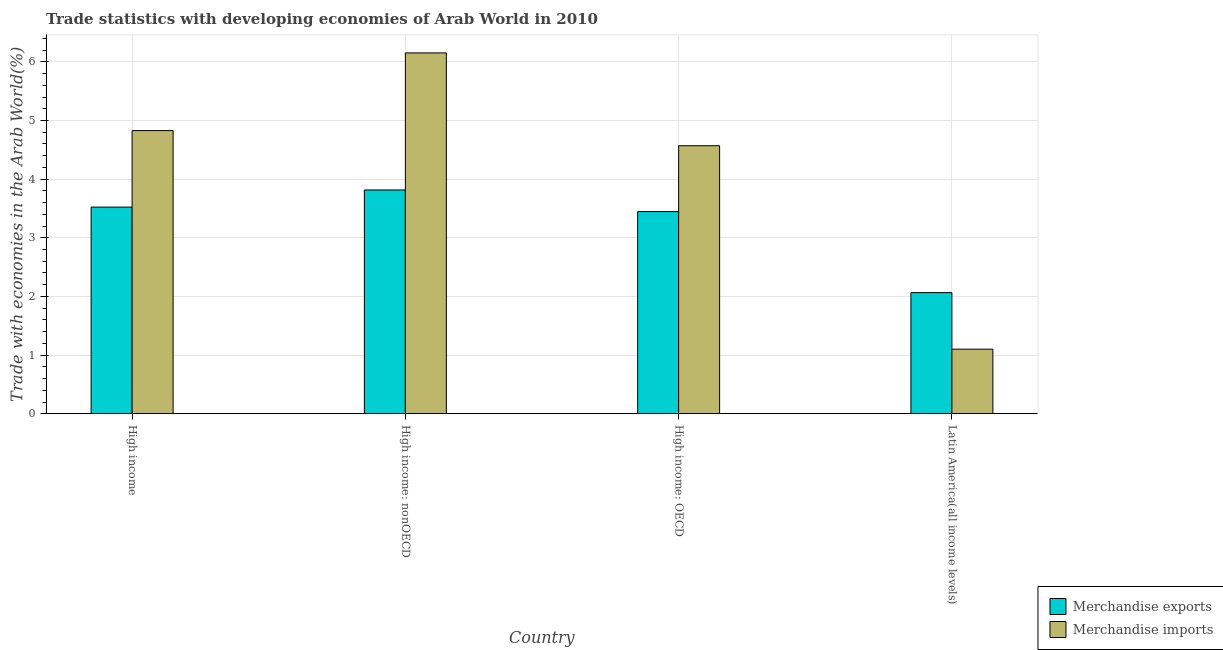How many different coloured bars are there?
Offer a terse response. 2. How many groups of bars are there?
Keep it short and to the point. 4. Are the number of bars per tick equal to the number of legend labels?
Your response must be concise. Yes. Are the number of bars on each tick of the X-axis equal?
Your answer should be very brief. Yes. How many bars are there on the 4th tick from the left?
Keep it short and to the point. 2. What is the label of the 3rd group of bars from the left?
Ensure brevity in your answer.  High income: OECD. In how many cases, is the number of bars for a given country not equal to the number of legend labels?
Give a very brief answer. 0. What is the merchandise exports in High income: nonOECD?
Your answer should be very brief. 3.82. Across all countries, what is the maximum merchandise imports?
Offer a terse response. 6.15. Across all countries, what is the minimum merchandise exports?
Offer a very short reply. 2.07. In which country was the merchandise imports maximum?
Make the answer very short. High income: nonOECD. In which country was the merchandise imports minimum?
Keep it short and to the point. Latin America(all income levels). What is the total merchandise imports in the graph?
Your response must be concise. 16.65. What is the difference between the merchandise imports in High income and that in High income: nonOECD?
Provide a succinct answer. -1.32. What is the difference between the merchandise exports in Latin America(all income levels) and the merchandise imports in High income: nonOECD?
Your response must be concise. -4.09. What is the average merchandise imports per country?
Offer a very short reply. 4.16. What is the difference between the merchandise imports and merchandise exports in High income: nonOECD?
Keep it short and to the point. 2.34. What is the ratio of the merchandise imports in High income to that in High income: nonOECD?
Your answer should be compact. 0.78. Is the difference between the merchandise imports in High income: OECD and Latin America(all income levels) greater than the difference between the merchandise exports in High income: OECD and Latin America(all income levels)?
Your response must be concise. Yes. What is the difference between the highest and the second highest merchandise exports?
Offer a very short reply. 0.29. What is the difference between the highest and the lowest merchandise exports?
Your answer should be compact. 1.75. What does the 2nd bar from the left in High income represents?
Your answer should be very brief. Merchandise imports. What does the 2nd bar from the right in Latin America(all income levels) represents?
Your answer should be very brief. Merchandise exports. How many countries are there in the graph?
Provide a short and direct response. 4. Does the graph contain any zero values?
Make the answer very short. No. Does the graph contain grids?
Your response must be concise. Yes. How many legend labels are there?
Provide a succinct answer. 2. What is the title of the graph?
Provide a short and direct response. Trade statistics with developing economies of Arab World in 2010. What is the label or title of the X-axis?
Provide a short and direct response. Country. What is the label or title of the Y-axis?
Make the answer very short. Trade with economies in the Arab World(%). What is the Trade with economies in the Arab World(%) in Merchandise exports in High income?
Give a very brief answer. 3.52. What is the Trade with economies in the Arab World(%) in Merchandise imports in High income?
Provide a short and direct response. 4.83. What is the Trade with economies in the Arab World(%) in Merchandise exports in High income: nonOECD?
Your answer should be compact. 3.82. What is the Trade with economies in the Arab World(%) in Merchandise imports in High income: nonOECD?
Offer a terse response. 6.15. What is the Trade with economies in the Arab World(%) of Merchandise exports in High income: OECD?
Keep it short and to the point. 3.45. What is the Trade with economies in the Arab World(%) in Merchandise imports in High income: OECD?
Give a very brief answer. 4.57. What is the Trade with economies in the Arab World(%) of Merchandise exports in Latin America(all income levels)?
Your response must be concise. 2.07. What is the Trade with economies in the Arab World(%) of Merchandise imports in Latin America(all income levels)?
Give a very brief answer. 1.1. Across all countries, what is the maximum Trade with economies in the Arab World(%) of Merchandise exports?
Offer a very short reply. 3.82. Across all countries, what is the maximum Trade with economies in the Arab World(%) of Merchandise imports?
Provide a short and direct response. 6.15. Across all countries, what is the minimum Trade with economies in the Arab World(%) in Merchandise exports?
Provide a short and direct response. 2.07. Across all countries, what is the minimum Trade with economies in the Arab World(%) in Merchandise imports?
Provide a succinct answer. 1.1. What is the total Trade with economies in the Arab World(%) of Merchandise exports in the graph?
Keep it short and to the point. 12.85. What is the total Trade with economies in the Arab World(%) of Merchandise imports in the graph?
Your answer should be compact. 16.65. What is the difference between the Trade with economies in the Arab World(%) of Merchandise exports in High income and that in High income: nonOECD?
Your answer should be compact. -0.29. What is the difference between the Trade with economies in the Arab World(%) of Merchandise imports in High income and that in High income: nonOECD?
Offer a terse response. -1.32. What is the difference between the Trade with economies in the Arab World(%) of Merchandise exports in High income and that in High income: OECD?
Offer a very short reply. 0.08. What is the difference between the Trade with economies in the Arab World(%) in Merchandise imports in High income and that in High income: OECD?
Provide a succinct answer. 0.26. What is the difference between the Trade with economies in the Arab World(%) in Merchandise exports in High income and that in Latin America(all income levels)?
Offer a very short reply. 1.46. What is the difference between the Trade with economies in the Arab World(%) of Merchandise imports in High income and that in Latin America(all income levels)?
Your answer should be very brief. 3.73. What is the difference between the Trade with economies in the Arab World(%) in Merchandise exports in High income: nonOECD and that in High income: OECD?
Offer a very short reply. 0.37. What is the difference between the Trade with economies in the Arab World(%) in Merchandise imports in High income: nonOECD and that in High income: OECD?
Offer a terse response. 1.58. What is the difference between the Trade with economies in the Arab World(%) of Merchandise exports in High income: nonOECD and that in Latin America(all income levels)?
Give a very brief answer. 1.75. What is the difference between the Trade with economies in the Arab World(%) in Merchandise imports in High income: nonOECD and that in Latin America(all income levels)?
Offer a terse response. 5.05. What is the difference between the Trade with economies in the Arab World(%) in Merchandise exports in High income: OECD and that in Latin America(all income levels)?
Your answer should be compact. 1.38. What is the difference between the Trade with economies in the Arab World(%) of Merchandise imports in High income: OECD and that in Latin America(all income levels)?
Keep it short and to the point. 3.47. What is the difference between the Trade with economies in the Arab World(%) in Merchandise exports in High income and the Trade with economies in the Arab World(%) in Merchandise imports in High income: nonOECD?
Provide a succinct answer. -2.63. What is the difference between the Trade with economies in the Arab World(%) of Merchandise exports in High income and the Trade with economies in the Arab World(%) of Merchandise imports in High income: OECD?
Give a very brief answer. -1.05. What is the difference between the Trade with economies in the Arab World(%) of Merchandise exports in High income and the Trade with economies in the Arab World(%) of Merchandise imports in Latin America(all income levels)?
Your answer should be compact. 2.42. What is the difference between the Trade with economies in the Arab World(%) in Merchandise exports in High income: nonOECD and the Trade with economies in the Arab World(%) in Merchandise imports in High income: OECD?
Provide a short and direct response. -0.75. What is the difference between the Trade with economies in the Arab World(%) in Merchandise exports in High income: nonOECD and the Trade with economies in the Arab World(%) in Merchandise imports in Latin America(all income levels)?
Provide a short and direct response. 2.71. What is the difference between the Trade with economies in the Arab World(%) of Merchandise exports in High income: OECD and the Trade with economies in the Arab World(%) of Merchandise imports in Latin America(all income levels)?
Provide a short and direct response. 2.35. What is the average Trade with economies in the Arab World(%) of Merchandise exports per country?
Ensure brevity in your answer.  3.21. What is the average Trade with economies in the Arab World(%) of Merchandise imports per country?
Give a very brief answer. 4.16. What is the difference between the Trade with economies in the Arab World(%) in Merchandise exports and Trade with economies in the Arab World(%) in Merchandise imports in High income?
Your answer should be compact. -1.3. What is the difference between the Trade with economies in the Arab World(%) of Merchandise exports and Trade with economies in the Arab World(%) of Merchandise imports in High income: nonOECD?
Give a very brief answer. -2.34. What is the difference between the Trade with economies in the Arab World(%) of Merchandise exports and Trade with economies in the Arab World(%) of Merchandise imports in High income: OECD?
Provide a succinct answer. -1.12. What is the difference between the Trade with economies in the Arab World(%) in Merchandise exports and Trade with economies in the Arab World(%) in Merchandise imports in Latin America(all income levels)?
Provide a short and direct response. 0.96. What is the ratio of the Trade with economies in the Arab World(%) in Merchandise exports in High income to that in High income: nonOECD?
Make the answer very short. 0.92. What is the ratio of the Trade with economies in the Arab World(%) in Merchandise imports in High income to that in High income: nonOECD?
Give a very brief answer. 0.78. What is the ratio of the Trade with economies in the Arab World(%) in Merchandise exports in High income to that in High income: OECD?
Ensure brevity in your answer.  1.02. What is the ratio of the Trade with economies in the Arab World(%) in Merchandise imports in High income to that in High income: OECD?
Ensure brevity in your answer.  1.06. What is the ratio of the Trade with economies in the Arab World(%) of Merchandise exports in High income to that in Latin America(all income levels)?
Your response must be concise. 1.71. What is the ratio of the Trade with economies in the Arab World(%) of Merchandise imports in High income to that in Latin America(all income levels)?
Offer a very short reply. 4.38. What is the ratio of the Trade with economies in the Arab World(%) in Merchandise exports in High income: nonOECD to that in High income: OECD?
Your answer should be very brief. 1.11. What is the ratio of the Trade with economies in the Arab World(%) in Merchandise imports in High income: nonOECD to that in High income: OECD?
Offer a very short reply. 1.35. What is the ratio of the Trade with economies in the Arab World(%) of Merchandise exports in High income: nonOECD to that in Latin America(all income levels)?
Offer a terse response. 1.85. What is the ratio of the Trade with economies in the Arab World(%) in Merchandise imports in High income: nonOECD to that in Latin America(all income levels)?
Offer a very short reply. 5.59. What is the ratio of the Trade with economies in the Arab World(%) of Merchandise exports in High income: OECD to that in Latin America(all income levels)?
Offer a terse response. 1.67. What is the ratio of the Trade with economies in the Arab World(%) in Merchandise imports in High income: OECD to that in Latin America(all income levels)?
Make the answer very short. 4.15. What is the difference between the highest and the second highest Trade with economies in the Arab World(%) of Merchandise exports?
Make the answer very short. 0.29. What is the difference between the highest and the second highest Trade with economies in the Arab World(%) of Merchandise imports?
Offer a very short reply. 1.32. What is the difference between the highest and the lowest Trade with economies in the Arab World(%) in Merchandise exports?
Offer a very short reply. 1.75. What is the difference between the highest and the lowest Trade with economies in the Arab World(%) of Merchandise imports?
Your answer should be very brief. 5.05. 